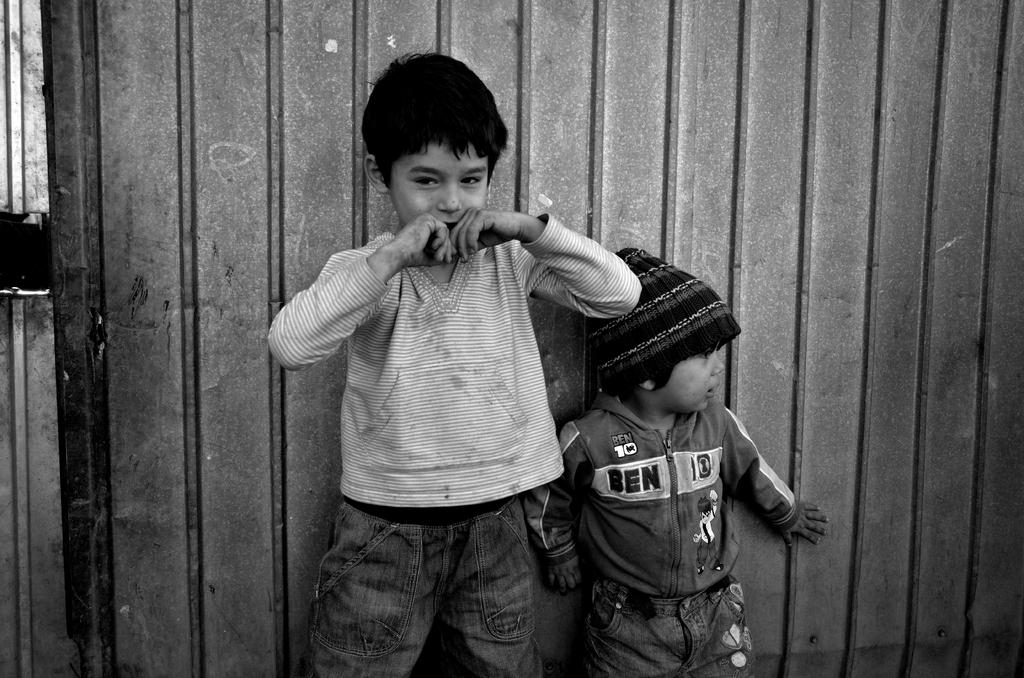What is the color scheme of the image? The image is black and white. How many children are present in the image? There are two children standing in the image. What can be seen in the background of the image? There is a metal object in the background that resembles a wall. What type of leaf is falling from the sky in the image? There is no leaf falling from the sky in the image, as it is a black and white image with no visible sky or vegetation. 